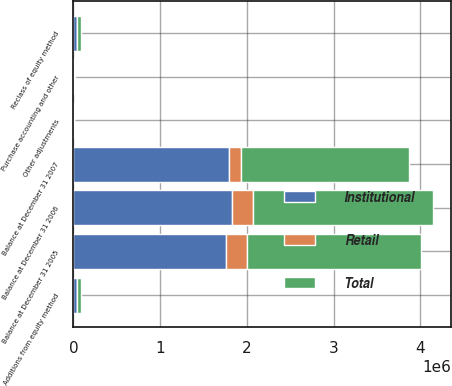<chart> <loc_0><loc_0><loc_500><loc_500><stacked_bar_chart><ecel><fcel>Balance at December 31 2005<fcel>Additions from equity method<fcel>Other adjustments<fcel>Balance at December 31 2006<fcel>Reclass of equity method<fcel>Purchase accounting and other<fcel>Balance at December 31 2007<nl><fcel>Institutional<fcel>1.76185e+06<fcel>38668<fcel>1500<fcel>1.82808e+06<fcel>38668<fcel>6191<fcel>1.79561e+06<nl><fcel>Retail<fcel>241608<fcel>4296<fcel>1069<fcel>244835<fcel>4296<fcel>2170<fcel>137760<nl><fcel>Total<fcel>2.00346e+06<fcel>42964<fcel>431<fcel>2.07292e+06<fcel>42964<fcel>8361<fcel>1.93337e+06<nl></chart> 